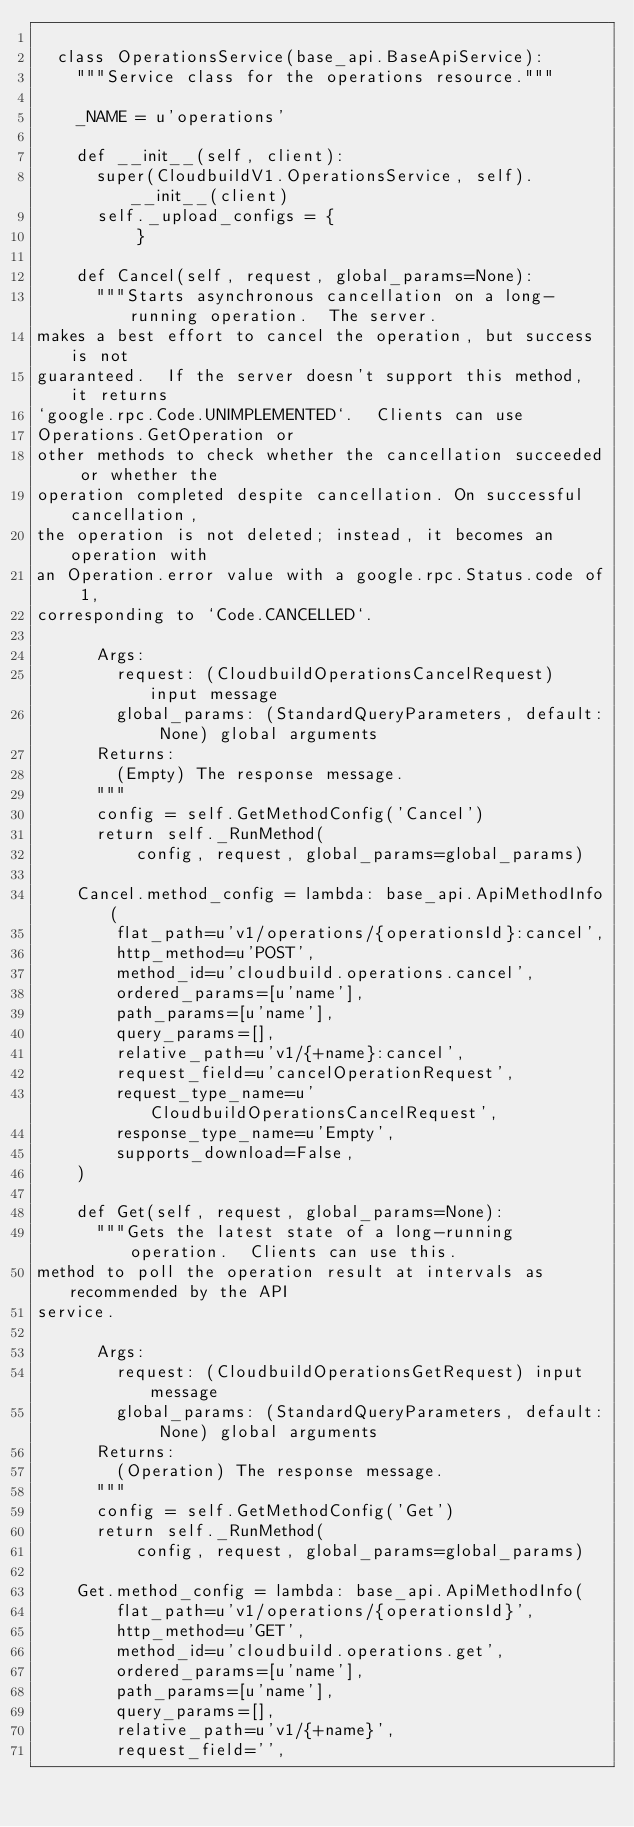<code> <loc_0><loc_0><loc_500><loc_500><_Python_>
  class OperationsService(base_api.BaseApiService):
    """Service class for the operations resource."""

    _NAME = u'operations'

    def __init__(self, client):
      super(CloudbuildV1.OperationsService, self).__init__(client)
      self._upload_configs = {
          }

    def Cancel(self, request, global_params=None):
      """Starts asynchronous cancellation on a long-running operation.  The server.
makes a best effort to cancel the operation, but success is not
guaranteed.  If the server doesn't support this method, it returns
`google.rpc.Code.UNIMPLEMENTED`.  Clients can use
Operations.GetOperation or
other methods to check whether the cancellation succeeded or whether the
operation completed despite cancellation. On successful cancellation,
the operation is not deleted; instead, it becomes an operation with
an Operation.error value with a google.rpc.Status.code of 1,
corresponding to `Code.CANCELLED`.

      Args:
        request: (CloudbuildOperationsCancelRequest) input message
        global_params: (StandardQueryParameters, default: None) global arguments
      Returns:
        (Empty) The response message.
      """
      config = self.GetMethodConfig('Cancel')
      return self._RunMethod(
          config, request, global_params=global_params)

    Cancel.method_config = lambda: base_api.ApiMethodInfo(
        flat_path=u'v1/operations/{operationsId}:cancel',
        http_method=u'POST',
        method_id=u'cloudbuild.operations.cancel',
        ordered_params=[u'name'],
        path_params=[u'name'],
        query_params=[],
        relative_path=u'v1/{+name}:cancel',
        request_field=u'cancelOperationRequest',
        request_type_name=u'CloudbuildOperationsCancelRequest',
        response_type_name=u'Empty',
        supports_download=False,
    )

    def Get(self, request, global_params=None):
      """Gets the latest state of a long-running operation.  Clients can use this.
method to poll the operation result at intervals as recommended by the API
service.

      Args:
        request: (CloudbuildOperationsGetRequest) input message
        global_params: (StandardQueryParameters, default: None) global arguments
      Returns:
        (Operation) The response message.
      """
      config = self.GetMethodConfig('Get')
      return self._RunMethod(
          config, request, global_params=global_params)

    Get.method_config = lambda: base_api.ApiMethodInfo(
        flat_path=u'v1/operations/{operationsId}',
        http_method=u'GET',
        method_id=u'cloudbuild.operations.get',
        ordered_params=[u'name'],
        path_params=[u'name'],
        query_params=[],
        relative_path=u'v1/{+name}',
        request_field='',</code> 